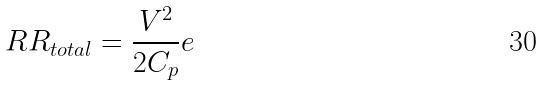Convert formula to latex. <formula><loc_0><loc_0><loc_500><loc_500>R R _ { t o t a l } = \frac { V ^ { 2 } } { 2 C _ { p } } e</formula> 